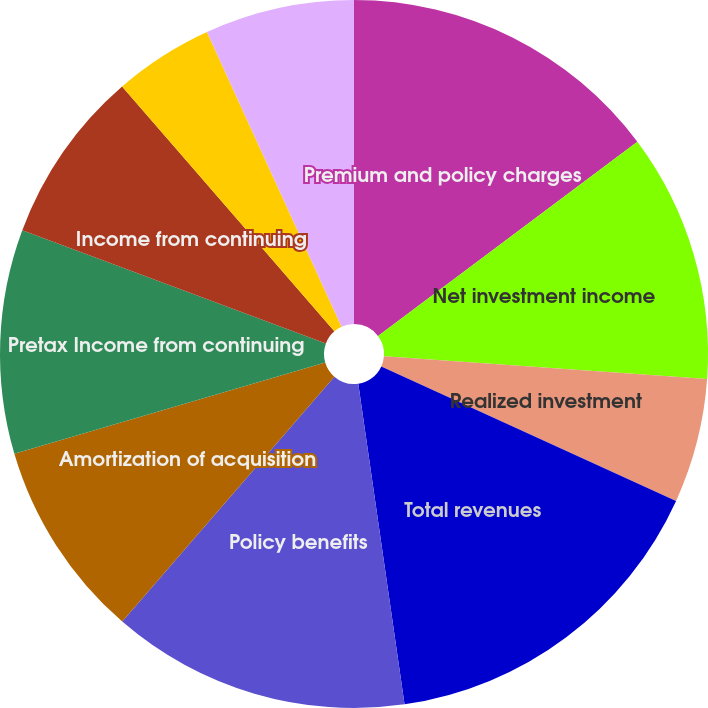Convert chart. <chart><loc_0><loc_0><loc_500><loc_500><pie_chart><fcel>Premium and policy charges<fcel>Net investment income<fcel>Realized investment<fcel>Total revenues<fcel>Policy benefits<fcel>Amortization of acquisition<fcel>Pretax Income from continuing<fcel>Income from continuing<fcel>Income from discontinued<fcel>Net income<nl><fcel>14.77%<fcel>11.36%<fcel>5.68%<fcel>15.91%<fcel>13.64%<fcel>9.09%<fcel>10.23%<fcel>7.95%<fcel>4.55%<fcel>6.82%<nl></chart> 